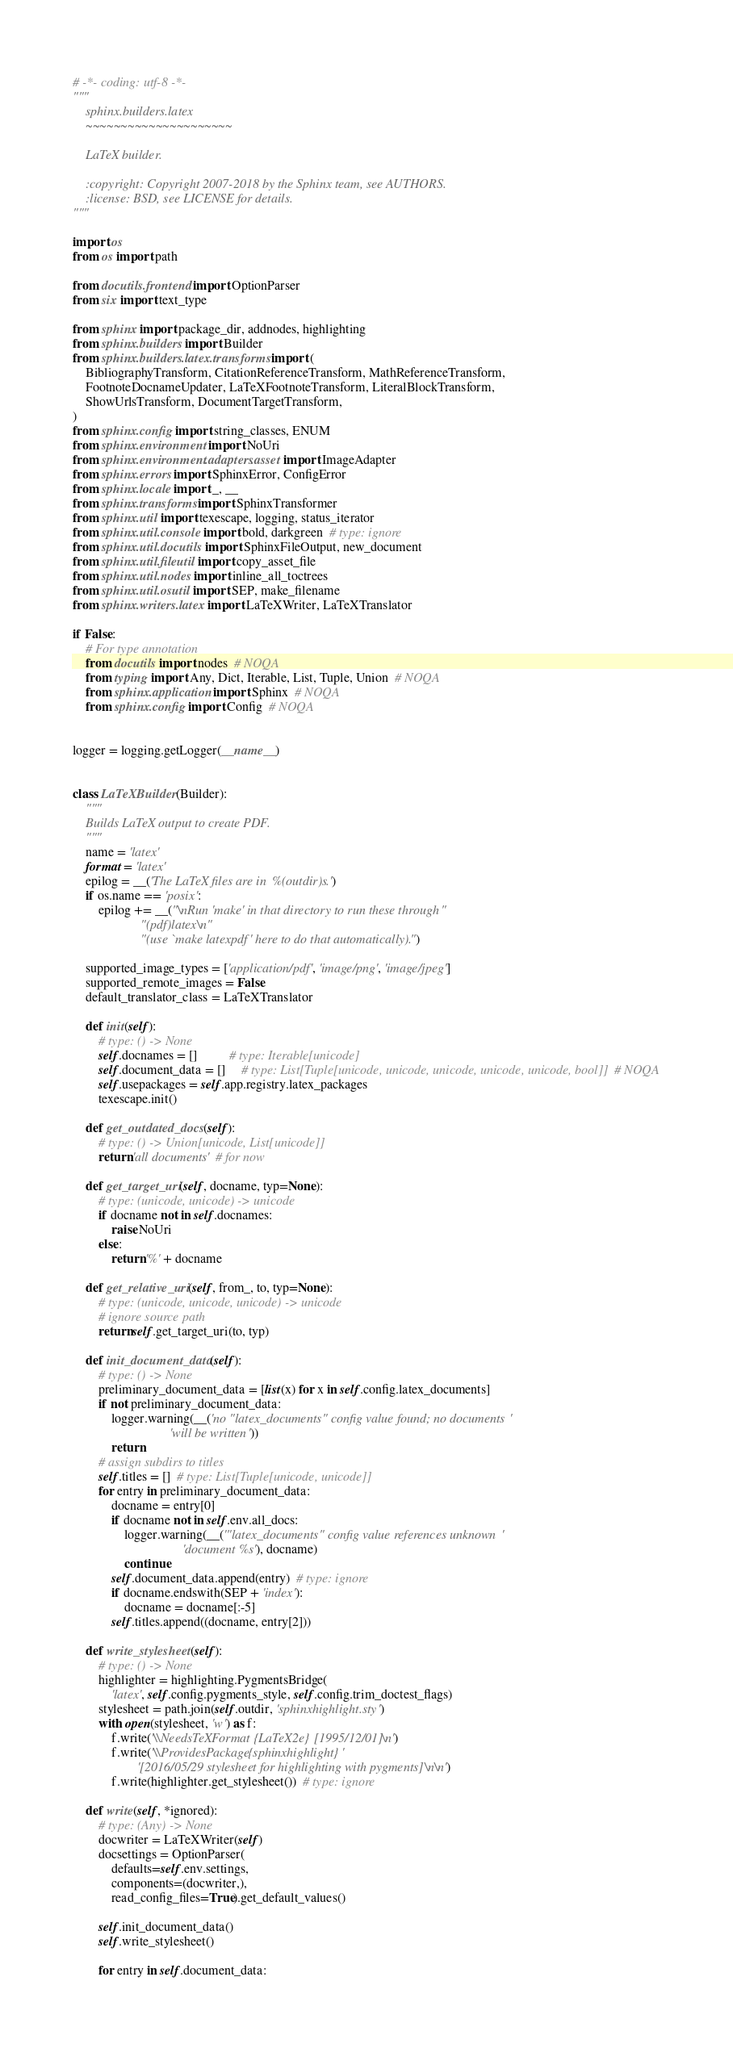Convert code to text. <code><loc_0><loc_0><loc_500><loc_500><_Python_># -*- coding: utf-8 -*-
"""
    sphinx.builders.latex
    ~~~~~~~~~~~~~~~~~~~~~

    LaTeX builder.

    :copyright: Copyright 2007-2018 by the Sphinx team, see AUTHORS.
    :license: BSD, see LICENSE for details.
"""

import os
from os import path

from docutils.frontend import OptionParser
from six import text_type

from sphinx import package_dir, addnodes, highlighting
from sphinx.builders import Builder
from sphinx.builders.latex.transforms import (
    BibliographyTransform, CitationReferenceTransform, MathReferenceTransform,
    FootnoteDocnameUpdater, LaTeXFootnoteTransform, LiteralBlockTransform,
    ShowUrlsTransform, DocumentTargetTransform,
)
from sphinx.config import string_classes, ENUM
from sphinx.environment import NoUri
from sphinx.environment.adapters.asset import ImageAdapter
from sphinx.errors import SphinxError, ConfigError
from sphinx.locale import _, __
from sphinx.transforms import SphinxTransformer
from sphinx.util import texescape, logging, status_iterator
from sphinx.util.console import bold, darkgreen  # type: ignore
from sphinx.util.docutils import SphinxFileOutput, new_document
from sphinx.util.fileutil import copy_asset_file
from sphinx.util.nodes import inline_all_toctrees
from sphinx.util.osutil import SEP, make_filename
from sphinx.writers.latex import LaTeXWriter, LaTeXTranslator

if False:
    # For type annotation
    from docutils import nodes  # NOQA
    from typing import Any, Dict, Iterable, List, Tuple, Union  # NOQA
    from sphinx.application import Sphinx  # NOQA
    from sphinx.config import Config  # NOQA


logger = logging.getLogger(__name__)


class LaTeXBuilder(Builder):
    """
    Builds LaTeX output to create PDF.
    """
    name = 'latex'
    format = 'latex'
    epilog = __('The LaTeX files are in %(outdir)s.')
    if os.name == 'posix':
        epilog += __("\nRun 'make' in that directory to run these through "
                     "(pdf)latex\n"
                     "(use `make latexpdf' here to do that automatically).")

    supported_image_types = ['application/pdf', 'image/png', 'image/jpeg']
    supported_remote_images = False
    default_translator_class = LaTeXTranslator

    def init(self):
        # type: () -> None
        self.docnames = []          # type: Iterable[unicode]
        self.document_data = []     # type: List[Tuple[unicode, unicode, unicode, unicode, unicode, bool]]  # NOQA
        self.usepackages = self.app.registry.latex_packages
        texescape.init()

    def get_outdated_docs(self):
        # type: () -> Union[unicode, List[unicode]]
        return 'all documents'  # for now

    def get_target_uri(self, docname, typ=None):
        # type: (unicode, unicode) -> unicode
        if docname not in self.docnames:
            raise NoUri
        else:
            return '%' + docname

    def get_relative_uri(self, from_, to, typ=None):
        # type: (unicode, unicode, unicode) -> unicode
        # ignore source path
        return self.get_target_uri(to, typ)

    def init_document_data(self):
        # type: () -> None
        preliminary_document_data = [list(x) for x in self.config.latex_documents]
        if not preliminary_document_data:
            logger.warning(__('no "latex_documents" config value found; no documents '
                              'will be written'))
            return
        # assign subdirs to titles
        self.titles = []  # type: List[Tuple[unicode, unicode]]
        for entry in preliminary_document_data:
            docname = entry[0]
            if docname not in self.env.all_docs:
                logger.warning(__('"latex_documents" config value references unknown '
                                  'document %s'), docname)
                continue
            self.document_data.append(entry)  # type: ignore
            if docname.endswith(SEP + 'index'):
                docname = docname[:-5]
            self.titles.append((docname, entry[2]))

    def write_stylesheet(self):
        # type: () -> None
        highlighter = highlighting.PygmentsBridge(
            'latex', self.config.pygments_style, self.config.trim_doctest_flags)
        stylesheet = path.join(self.outdir, 'sphinxhighlight.sty')
        with open(stylesheet, 'w') as f:
            f.write('\\NeedsTeXFormat{LaTeX2e}[1995/12/01]\n')
            f.write('\\ProvidesPackage{sphinxhighlight}'
                    '[2016/05/29 stylesheet for highlighting with pygments]\n\n')
            f.write(highlighter.get_stylesheet())  # type: ignore

    def write(self, *ignored):
        # type: (Any) -> None
        docwriter = LaTeXWriter(self)
        docsettings = OptionParser(
            defaults=self.env.settings,
            components=(docwriter,),
            read_config_files=True).get_default_values()

        self.init_document_data()
        self.write_stylesheet()

        for entry in self.document_data:</code> 